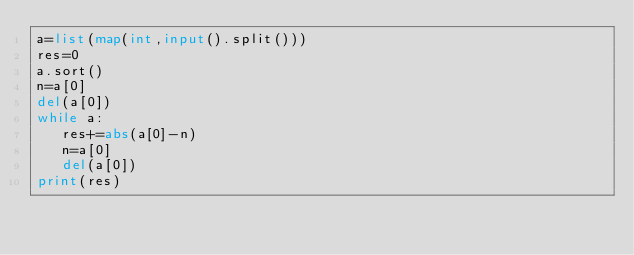Convert code to text. <code><loc_0><loc_0><loc_500><loc_500><_Python_>a=list(map(int,input().split()))
res=0
a.sort()
n=a[0]
del(a[0])
while a:
   res+=abs(a[0]-n)
   n=a[0]
   del(a[0])
print(res)</code> 